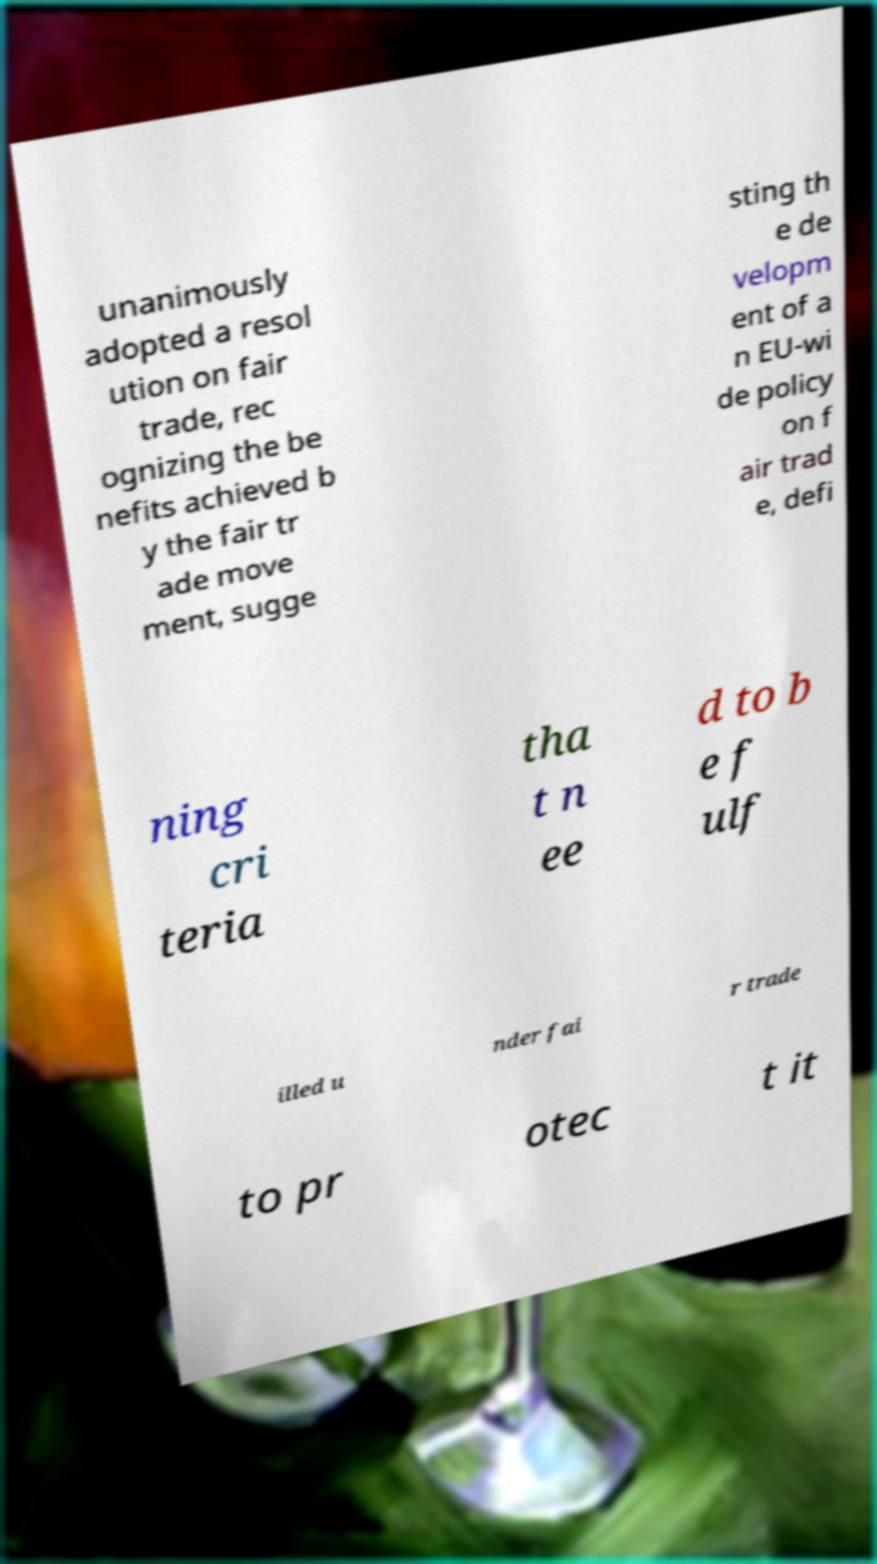Can you accurately transcribe the text from the provided image for me? unanimously adopted a resol ution on fair trade, rec ognizing the be nefits achieved b y the fair tr ade move ment, sugge sting th e de velopm ent of a n EU-wi de policy on f air trad e, defi ning cri teria tha t n ee d to b e f ulf illed u nder fai r trade to pr otec t it 